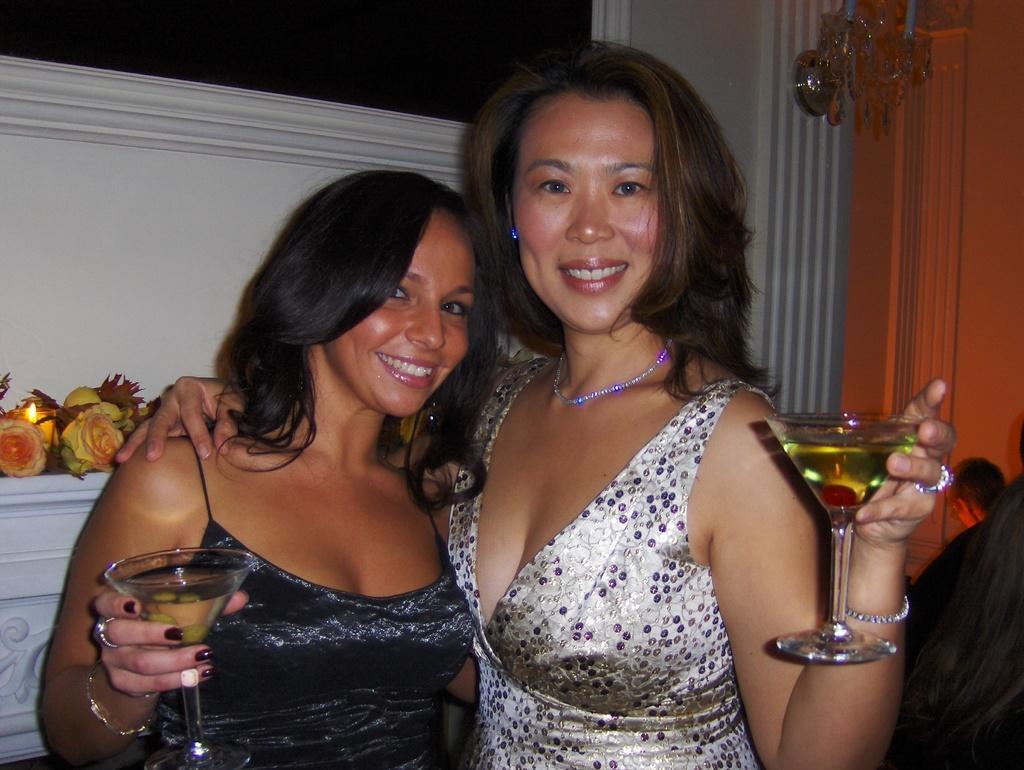Could you give a brief overview of what you see in this image? There are two ladies standing , smiling and holding two glasses. In the background there are flowers, wall and some decorating item. 